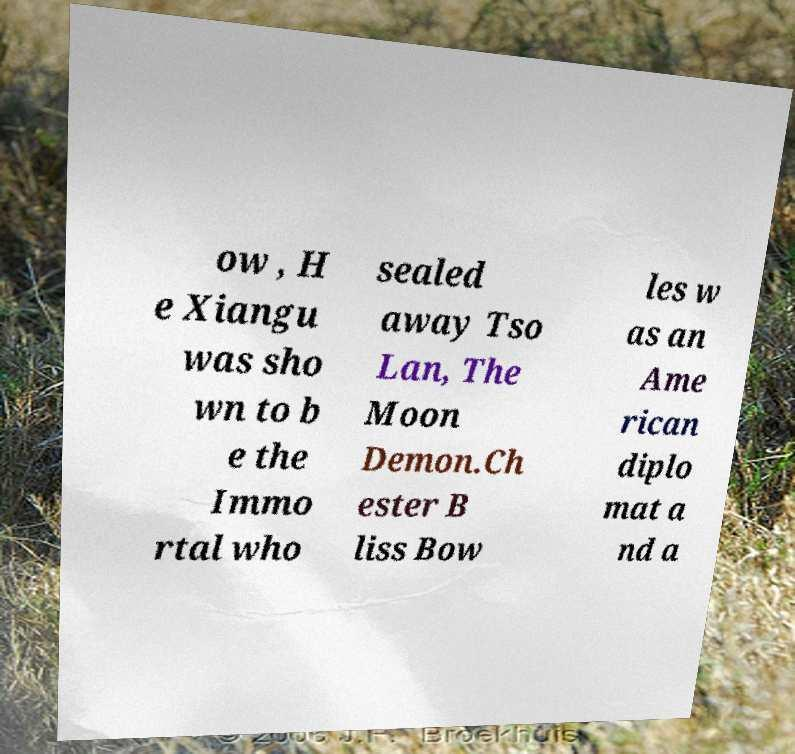Could you extract and type out the text from this image? ow , H e Xiangu was sho wn to b e the Immo rtal who sealed away Tso Lan, The Moon Demon.Ch ester B liss Bow les w as an Ame rican diplo mat a nd a 